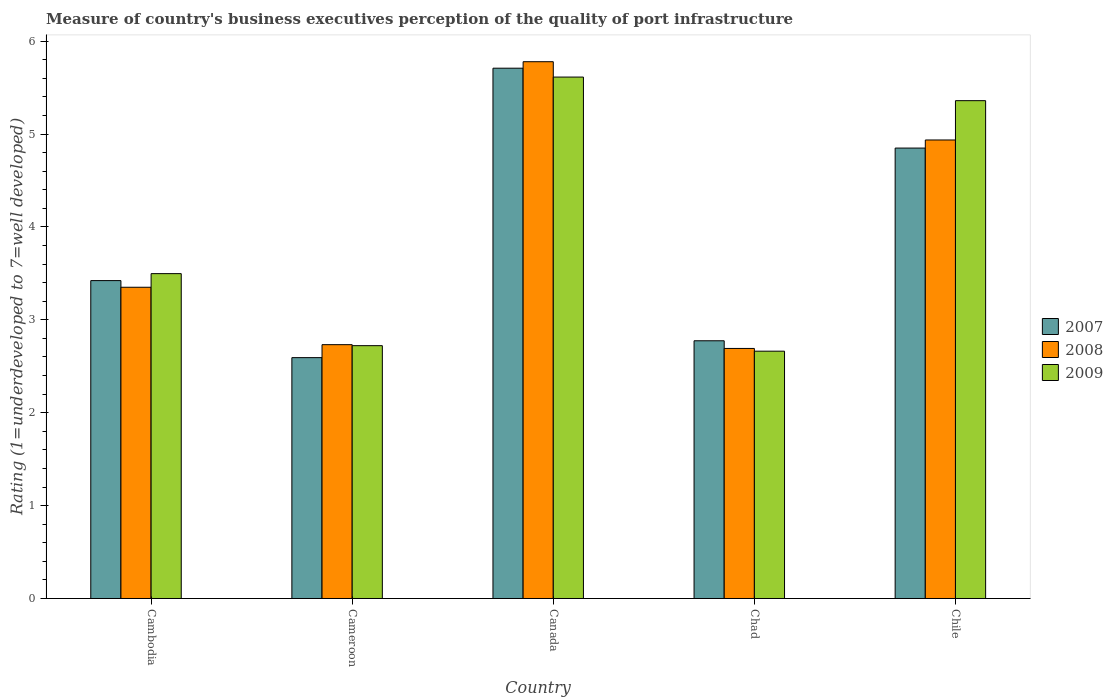How many different coloured bars are there?
Keep it short and to the point. 3. How many groups of bars are there?
Keep it short and to the point. 5. Are the number of bars per tick equal to the number of legend labels?
Your answer should be compact. Yes. How many bars are there on the 5th tick from the left?
Give a very brief answer. 3. What is the label of the 1st group of bars from the left?
Provide a succinct answer. Cambodia. In how many cases, is the number of bars for a given country not equal to the number of legend labels?
Make the answer very short. 0. What is the ratings of the quality of port infrastructure in 2008 in Cameroon?
Ensure brevity in your answer.  2.73. Across all countries, what is the maximum ratings of the quality of port infrastructure in 2007?
Your response must be concise. 5.71. Across all countries, what is the minimum ratings of the quality of port infrastructure in 2007?
Offer a very short reply. 2.59. In which country was the ratings of the quality of port infrastructure in 2008 minimum?
Offer a terse response. Chad. What is the total ratings of the quality of port infrastructure in 2009 in the graph?
Offer a very short reply. 19.85. What is the difference between the ratings of the quality of port infrastructure in 2008 in Cameroon and that in Canada?
Make the answer very short. -3.05. What is the difference between the ratings of the quality of port infrastructure in 2007 in Cameroon and the ratings of the quality of port infrastructure in 2008 in Canada?
Offer a terse response. -3.19. What is the average ratings of the quality of port infrastructure in 2008 per country?
Provide a succinct answer. 3.9. What is the difference between the ratings of the quality of port infrastructure of/in 2009 and ratings of the quality of port infrastructure of/in 2008 in Cambodia?
Offer a very short reply. 0.15. What is the ratio of the ratings of the quality of port infrastructure in 2008 in Canada to that in Chad?
Give a very brief answer. 2.15. What is the difference between the highest and the second highest ratings of the quality of port infrastructure in 2007?
Provide a short and direct response. -1.43. What is the difference between the highest and the lowest ratings of the quality of port infrastructure in 2008?
Your answer should be compact. 3.09. In how many countries, is the ratings of the quality of port infrastructure in 2008 greater than the average ratings of the quality of port infrastructure in 2008 taken over all countries?
Ensure brevity in your answer.  2. What does the 3rd bar from the left in Cambodia represents?
Your response must be concise. 2009. Is it the case that in every country, the sum of the ratings of the quality of port infrastructure in 2007 and ratings of the quality of port infrastructure in 2008 is greater than the ratings of the quality of port infrastructure in 2009?
Make the answer very short. Yes. Are all the bars in the graph horizontal?
Make the answer very short. No. How many countries are there in the graph?
Offer a terse response. 5. Does the graph contain any zero values?
Ensure brevity in your answer.  No. Does the graph contain grids?
Keep it short and to the point. No. How many legend labels are there?
Your answer should be compact. 3. How are the legend labels stacked?
Ensure brevity in your answer.  Vertical. What is the title of the graph?
Give a very brief answer. Measure of country's business executives perception of the quality of port infrastructure. Does "1997" appear as one of the legend labels in the graph?
Your answer should be compact. No. What is the label or title of the Y-axis?
Provide a succinct answer. Rating (1=underdeveloped to 7=well developed). What is the Rating (1=underdeveloped to 7=well developed) of 2007 in Cambodia?
Provide a succinct answer. 3.42. What is the Rating (1=underdeveloped to 7=well developed) in 2008 in Cambodia?
Offer a very short reply. 3.35. What is the Rating (1=underdeveloped to 7=well developed) of 2009 in Cambodia?
Your answer should be very brief. 3.5. What is the Rating (1=underdeveloped to 7=well developed) in 2007 in Cameroon?
Provide a short and direct response. 2.59. What is the Rating (1=underdeveloped to 7=well developed) in 2008 in Cameroon?
Ensure brevity in your answer.  2.73. What is the Rating (1=underdeveloped to 7=well developed) of 2009 in Cameroon?
Your answer should be compact. 2.72. What is the Rating (1=underdeveloped to 7=well developed) in 2007 in Canada?
Offer a terse response. 5.71. What is the Rating (1=underdeveloped to 7=well developed) of 2008 in Canada?
Your answer should be compact. 5.78. What is the Rating (1=underdeveloped to 7=well developed) of 2009 in Canada?
Offer a terse response. 5.61. What is the Rating (1=underdeveloped to 7=well developed) of 2007 in Chad?
Ensure brevity in your answer.  2.77. What is the Rating (1=underdeveloped to 7=well developed) of 2008 in Chad?
Your response must be concise. 2.69. What is the Rating (1=underdeveloped to 7=well developed) in 2009 in Chad?
Give a very brief answer. 2.66. What is the Rating (1=underdeveloped to 7=well developed) of 2007 in Chile?
Make the answer very short. 4.85. What is the Rating (1=underdeveloped to 7=well developed) of 2008 in Chile?
Provide a succinct answer. 4.94. What is the Rating (1=underdeveloped to 7=well developed) in 2009 in Chile?
Your answer should be compact. 5.36. Across all countries, what is the maximum Rating (1=underdeveloped to 7=well developed) in 2007?
Provide a short and direct response. 5.71. Across all countries, what is the maximum Rating (1=underdeveloped to 7=well developed) in 2008?
Make the answer very short. 5.78. Across all countries, what is the maximum Rating (1=underdeveloped to 7=well developed) of 2009?
Keep it short and to the point. 5.61. Across all countries, what is the minimum Rating (1=underdeveloped to 7=well developed) of 2007?
Provide a short and direct response. 2.59. Across all countries, what is the minimum Rating (1=underdeveloped to 7=well developed) in 2008?
Your answer should be very brief. 2.69. Across all countries, what is the minimum Rating (1=underdeveloped to 7=well developed) in 2009?
Ensure brevity in your answer.  2.66. What is the total Rating (1=underdeveloped to 7=well developed) of 2007 in the graph?
Give a very brief answer. 19.35. What is the total Rating (1=underdeveloped to 7=well developed) in 2008 in the graph?
Provide a succinct answer. 19.49. What is the total Rating (1=underdeveloped to 7=well developed) of 2009 in the graph?
Ensure brevity in your answer.  19.85. What is the difference between the Rating (1=underdeveloped to 7=well developed) of 2007 in Cambodia and that in Cameroon?
Keep it short and to the point. 0.83. What is the difference between the Rating (1=underdeveloped to 7=well developed) of 2008 in Cambodia and that in Cameroon?
Offer a terse response. 0.62. What is the difference between the Rating (1=underdeveloped to 7=well developed) of 2009 in Cambodia and that in Cameroon?
Offer a terse response. 0.78. What is the difference between the Rating (1=underdeveloped to 7=well developed) in 2007 in Cambodia and that in Canada?
Provide a succinct answer. -2.29. What is the difference between the Rating (1=underdeveloped to 7=well developed) in 2008 in Cambodia and that in Canada?
Provide a short and direct response. -2.43. What is the difference between the Rating (1=underdeveloped to 7=well developed) in 2009 in Cambodia and that in Canada?
Offer a very short reply. -2.12. What is the difference between the Rating (1=underdeveloped to 7=well developed) in 2007 in Cambodia and that in Chad?
Make the answer very short. 0.65. What is the difference between the Rating (1=underdeveloped to 7=well developed) in 2008 in Cambodia and that in Chad?
Offer a very short reply. 0.66. What is the difference between the Rating (1=underdeveloped to 7=well developed) in 2009 in Cambodia and that in Chad?
Provide a succinct answer. 0.83. What is the difference between the Rating (1=underdeveloped to 7=well developed) in 2007 in Cambodia and that in Chile?
Give a very brief answer. -1.43. What is the difference between the Rating (1=underdeveloped to 7=well developed) of 2008 in Cambodia and that in Chile?
Your answer should be very brief. -1.59. What is the difference between the Rating (1=underdeveloped to 7=well developed) in 2009 in Cambodia and that in Chile?
Ensure brevity in your answer.  -1.86. What is the difference between the Rating (1=underdeveloped to 7=well developed) of 2007 in Cameroon and that in Canada?
Provide a short and direct response. -3.12. What is the difference between the Rating (1=underdeveloped to 7=well developed) in 2008 in Cameroon and that in Canada?
Ensure brevity in your answer.  -3.05. What is the difference between the Rating (1=underdeveloped to 7=well developed) in 2009 in Cameroon and that in Canada?
Ensure brevity in your answer.  -2.89. What is the difference between the Rating (1=underdeveloped to 7=well developed) of 2007 in Cameroon and that in Chad?
Keep it short and to the point. -0.18. What is the difference between the Rating (1=underdeveloped to 7=well developed) in 2008 in Cameroon and that in Chad?
Provide a short and direct response. 0.04. What is the difference between the Rating (1=underdeveloped to 7=well developed) of 2009 in Cameroon and that in Chad?
Provide a short and direct response. 0.06. What is the difference between the Rating (1=underdeveloped to 7=well developed) in 2007 in Cameroon and that in Chile?
Provide a succinct answer. -2.26. What is the difference between the Rating (1=underdeveloped to 7=well developed) in 2008 in Cameroon and that in Chile?
Keep it short and to the point. -2.2. What is the difference between the Rating (1=underdeveloped to 7=well developed) of 2009 in Cameroon and that in Chile?
Offer a terse response. -2.64. What is the difference between the Rating (1=underdeveloped to 7=well developed) in 2007 in Canada and that in Chad?
Offer a terse response. 2.93. What is the difference between the Rating (1=underdeveloped to 7=well developed) of 2008 in Canada and that in Chad?
Give a very brief answer. 3.09. What is the difference between the Rating (1=underdeveloped to 7=well developed) in 2009 in Canada and that in Chad?
Give a very brief answer. 2.95. What is the difference between the Rating (1=underdeveloped to 7=well developed) in 2007 in Canada and that in Chile?
Your answer should be compact. 0.86. What is the difference between the Rating (1=underdeveloped to 7=well developed) of 2008 in Canada and that in Chile?
Offer a very short reply. 0.84. What is the difference between the Rating (1=underdeveloped to 7=well developed) in 2009 in Canada and that in Chile?
Provide a short and direct response. 0.25. What is the difference between the Rating (1=underdeveloped to 7=well developed) in 2007 in Chad and that in Chile?
Offer a very short reply. -2.07. What is the difference between the Rating (1=underdeveloped to 7=well developed) of 2008 in Chad and that in Chile?
Provide a succinct answer. -2.24. What is the difference between the Rating (1=underdeveloped to 7=well developed) of 2009 in Chad and that in Chile?
Keep it short and to the point. -2.7. What is the difference between the Rating (1=underdeveloped to 7=well developed) in 2007 in Cambodia and the Rating (1=underdeveloped to 7=well developed) in 2008 in Cameroon?
Provide a succinct answer. 0.69. What is the difference between the Rating (1=underdeveloped to 7=well developed) in 2007 in Cambodia and the Rating (1=underdeveloped to 7=well developed) in 2009 in Cameroon?
Your answer should be compact. 0.7. What is the difference between the Rating (1=underdeveloped to 7=well developed) in 2008 in Cambodia and the Rating (1=underdeveloped to 7=well developed) in 2009 in Cameroon?
Provide a short and direct response. 0.63. What is the difference between the Rating (1=underdeveloped to 7=well developed) in 2007 in Cambodia and the Rating (1=underdeveloped to 7=well developed) in 2008 in Canada?
Provide a short and direct response. -2.36. What is the difference between the Rating (1=underdeveloped to 7=well developed) of 2007 in Cambodia and the Rating (1=underdeveloped to 7=well developed) of 2009 in Canada?
Provide a short and direct response. -2.19. What is the difference between the Rating (1=underdeveloped to 7=well developed) in 2008 in Cambodia and the Rating (1=underdeveloped to 7=well developed) in 2009 in Canada?
Give a very brief answer. -2.26. What is the difference between the Rating (1=underdeveloped to 7=well developed) in 2007 in Cambodia and the Rating (1=underdeveloped to 7=well developed) in 2008 in Chad?
Offer a very short reply. 0.73. What is the difference between the Rating (1=underdeveloped to 7=well developed) of 2007 in Cambodia and the Rating (1=underdeveloped to 7=well developed) of 2009 in Chad?
Ensure brevity in your answer.  0.76. What is the difference between the Rating (1=underdeveloped to 7=well developed) in 2008 in Cambodia and the Rating (1=underdeveloped to 7=well developed) in 2009 in Chad?
Offer a terse response. 0.69. What is the difference between the Rating (1=underdeveloped to 7=well developed) in 2007 in Cambodia and the Rating (1=underdeveloped to 7=well developed) in 2008 in Chile?
Make the answer very short. -1.51. What is the difference between the Rating (1=underdeveloped to 7=well developed) in 2007 in Cambodia and the Rating (1=underdeveloped to 7=well developed) in 2009 in Chile?
Ensure brevity in your answer.  -1.94. What is the difference between the Rating (1=underdeveloped to 7=well developed) in 2008 in Cambodia and the Rating (1=underdeveloped to 7=well developed) in 2009 in Chile?
Provide a short and direct response. -2.01. What is the difference between the Rating (1=underdeveloped to 7=well developed) of 2007 in Cameroon and the Rating (1=underdeveloped to 7=well developed) of 2008 in Canada?
Your answer should be compact. -3.19. What is the difference between the Rating (1=underdeveloped to 7=well developed) of 2007 in Cameroon and the Rating (1=underdeveloped to 7=well developed) of 2009 in Canada?
Make the answer very short. -3.02. What is the difference between the Rating (1=underdeveloped to 7=well developed) of 2008 in Cameroon and the Rating (1=underdeveloped to 7=well developed) of 2009 in Canada?
Your answer should be compact. -2.88. What is the difference between the Rating (1=underdeveloped to 7=well developed) in 2007 in Cameroon and the Rating (1=underdeveloped to 7=well developed) in 2008 in Chad?
Offer a terse response. -0.1. What is the difference between the Rating (1=underdeveloped to 7=well developed) in 2007 in Cameroon and the Rating (1=underdeveloped to 7=well developed) in 2009 in Chad?
Ensure brevity in your answer.  -0.07. What is the difference between the Rating (1=underdeveloped to 7=well developed) of 2008 in Cameroon and the Rating (1=underdeveloped to 7=well developed) of 2009 in Chad?
Ensure brevity in your answer.  0.07. What is the difference between the Rating (1=underdeveloped to 7=well developed) in 2007 in Cameroon and the Rating (1=underdeveloped to 7=well developed) in 2008 in Chile?
Give a very brief answer. -2.34. What is the difference between the Rating (1=underdeveloped to 7=well developed) in 2007 in Cameroon and the Rating (1=underdeveloped to 7=well developed) in 2009 in Chile?
Give a very brief answer. -2.77. What is the difference between the Rating (1=underdeveloped to 7=well developed) in 2008 in Cameroon and the Rating (1=underdeveloped to 7=well developed) in 2009 in Chile?
Offer a terse response. -2.63. What is the difference between the Rating (1=underdeveloped to 7=well developed) in 2007 in Canada and the Rating (1=underdeveloped to 7=well developed) in 2008 in Chad?
Keep it short and to the point. 3.02. What is the difference between the Rating (1=underdeveloped to 7=well developed) of 2007 in Canada and the Rating (1=underdeveloped to 7=well developed) of 2009 in Chad?
Offer a very short reply. 3.05. What is the difference between the Rating (1=underdeveloped to 7=well developed) of 2008 in Canada and the Rating (1=underdeveloped to 7=well developed) of 2009 in Chad?
Provide a succinct answer. 3.12. What is the difference between the Rating (1=underdeveloped to 7=well developed) in 2007 in Canada and the Rating (1=underdeveloped to 7=well developed) in 2008 in Chile?
Offer a very short reply. 0.77. What is the difference between the Rating (1=underdeveloped to 7=well developed) in 2007 in Canada and the Rating (1=underdeveloped to 7=well developed) in 2009 in Chile?
Provide a succinct answer. 0.35. What is the difference between the Rating (1=underdeveloped to 7=well developed) in 2008 in Canada and the Rating (1=underdeveloped to 7=well developed) in 2009 in Chile?
Provide a succinct answer. 0.42. What is the difference between the Rating (1=underdeveloped to 7=well developed) of 2007 in Chad and the Rating (1=underdeveloped to 7=well developed) of 2008 in Chile?
Provide a short and direct response. -2.16. What is the difference between the Rating (1=underdeveloped to 7=well developed) of 2007 in Chad and the Rating (1=underdeveloped to 7=well developed) of 2009 in Chile?
Ensure brevity in your answer.  -2.58. What is the difference between the Rating (1=underdeveloped to 7=well developed) of 2008 in Chad and the Rating (1=underdeveloped to 7=well developed) of 2009 in Chile?
Your answer should be compact. -2.67. What is the average Rating (1=underdeveloped to 7=well developed) in 2007 per country?
Make the answer very short. 3.87. What is the average Rating (1=underdeveloped to 7=well developed) of 2008 per country?
Your answer should be very brief. 3.9. What is the average Rating (1=underdeveloped to 7=well developed) in 2009 per country?
Ensure brevity in your answer.  3.97. What is the difference between the Rating (1=underdeveloped to 7=well developed) of 2007 and Rating (1=underdeveloped to 7=well developed) of 2008 in Cambodia?
Offer a very short reply. 0.07. What is the difference between the Rating (1=underdeveloped to 7=well developed) of 2007 and Rating (1=underdeveloped to 7=well developed) of 2009 in Cambodia?
Keep it short and to the point. -0.08. What is the difference between the Rating (1=underdeveloped to 7=well developed) of 2008 and Rating (1=underdeveloped to 7=well developed) of 2009 in Cambodia?
Ensure brevity in your answer.  -0.15. What is the difference between the Rating (1=underdeveloped to 7=well developed) of 2007 and Rating (1=underdeveloped to 7=well developed) of 2008 in Cameroon?
Your answer should be very brief. -0.14. What is the difference between the Rating (1=underdeveloped to 7=well developed) in 2007 and Rating (1=underdeveloped to 7=well developed) in 2009 in Cameroon?
Your answer should be very brief. -0.13. What is the difference between the Rating (1=underdeveloped to 7=well developed) in 2008 and Rating (1=underdeveloped to 7=well developed) in 2009 in Cameroon?
Give a very brief answer. 0.01. What is the difference between the Rating (1=underdeveloped to 7=well developed) of 2007 and Rating (1=underdeveloped to 7=well developed) of 2008 in Canada?
Your answer should be very brief. -0.07. What is the difference between the Rating (1=underdeveloped to 7=well developed) of 2007 and Rating (1=underdeveloped to 7=well developed) of 2009 in Canada?
Keep it short and to the point. 0.1. What is the difference between the Rating (1=underdeveloped to 7=well developed) of 2008 and Rating (1=underdeveloped to 7=well developed) of 2009 in Canada?
Your answer should be very brief. 0.17. What is the difference between the Rating (1=underdeveloped to 7=well developed) in 2007 and Rating (1=underdeveloped to 7=well developed) in 2008 in Chad?
Your response must be concise. 0.08. What is the difference between the Rating (1=underdeveloped to 7=well developed) of 2007 and Rating (1=underdeveloped to 7=well developed) of 2009 in Chad?
Keep it short and to the point. 0.11. What is the difference between the Rating (1=underdeveloped to 7=well developed) in 2008 and Rating (1=underdeveloped to 7=well developed) in 2009 in Chad?
Keep it short and to the point. 0.03. What is the difference between the Rating (1=underdeveloped to 7=well developed) in 2007 and Rating (1=underdeveloped to 7=well developed) in 2008 in Chile?
Your answer should be very brief. -0.09. What is the difference between the Rating (1=underdeveloped to 7=well developed) of 2007 and Rating (1=underdeveloped to 7=well developed) of 2009 in Chile?
Offer a very short reply. -0.51. What is the difference between the Rating (1=underdeveloped to 7=well developed) in 2008 and Rating (1=underdeveloped to 7=well developed) in 2009 in Chile?
Ensure brevity in your answer.  -0.42. What is the ratio of the Rating (1=underdeveloped to 7=well developed) of 2007 in Cambodia to that in Cameroon?
Your response must be concise. 1.32. What is the ratio of the Rating (1=underdeveloped to 7=well developed) in 2008 in Cambodia to that in Cameroon?
Provide a short and direct response. 1.23. What is the ratio of the Rating (1=underdeveloped to 7=well developed) of 2009 in Cambodia to that in Cameroon?
Keep it short and to the point. 1.28. What is the ratio of the Rating (1=underdeveloped to 7=well developed) of 2007 in Cambodia to that in Canada?
Ensure brevity in your answer.  0.6. What is the ratio of the Rating (1=underdeveloped to 7=well developed) in 2008 in Cambodia to that in Canada?
Give a very brief answer. 0.58. What is the ratio of the Rating (1=underdeveloped to 7=well developed) of 2009 in Cambodia to that in Canada?
Provide a succinct answer. 0.62. What is the ratio of the Rating (1=underdeveloped to 7=well developed) in 2007 in Cambodia to that in Chad?
Offer a very short reply. 1.23. What is the ratio of the Rating (1=underdeveloped to 7=well developed) of 2008 in Cambodia to that in Chad?
Offer a very short reply. 1.24. What is the ratio of the Rating (1=underdeveloped to 7=well developed) in 2009 in Cambodia to that in Chad?
Your answer should be compact. 1.31. What is the ratio of the Rating (1=underdeveloped to 7=well developed) in 2007 in Cambodia to that in Chile?
Offer a terse response. 0.71. What is the ratio of the Rating (1=underdeveloped to 7=well developed) of 2008 in Cambodia to that in Chile?
Provide a succinct answer. 0.68. What is the ratio of the Rating (1=underdeveloped to 7=well developed) of 2009 in Cambodia to that in Chile?
Your answer should be compact. 0.65. What is the ratio of the Rating (1=underdeveloped to 7=well developed) in 2007 in Cameroon to that in Canada?
Ensure brevity in your answer.  0.45. What is the ratio of the Rating (1=underdeveloped to 7=well developed) of 2008 in Cameroon to that in Canada?
Ensure brevity in your answer.  0.47. What is the ratio of the Rating (1=underdeveloped to 7=well developed) in 2009 in Cameroon to that in Canada?
Provide a succinct answer. 0.48. What is the ratio of the Rating (1=underdeveloped to 7=well developed) in 2007 in Cameroon to that in Chad?
Offer a very short reply. 0.93. What is the ratio of the Rating (1=underdeveloped to 7=well developed) of 2008 in Cameroon to that in Chad?
Offer a terse response. 1.02. What is the ratio of the Rating (1=underdeveloped to 7=well developed) of 2009 in Cameroon to that in Chad?
Your response must be concise. 1.02. What is the ratio of the Rating (1=underdeveloped to 7=well developed) of 2007 in Cameroon to that in Chile?
Provide a short and direct response. 0.53. What is the ratio of the Rating (1=underdeveloped to 7=well developed) of 2008 in Cameroon to that in Chile?
Keep it short and to the point. 0.55. What is the ratio of the Rating (1=underdeveloped to 7=well developed) of 2009 in Cameroon to that in Chile?
Offer a very short reply. 0.51. What is the ratio of the Rating (1=underdeveloped to 7=well developed) in 2007 in Canada to that in Chad?
Make the answer very short. 2.06. What is the ratio of the Rating (1=underdeveloped to 7=well developed) of 2008 in Canada to that in Chad?
Your answer should be very brief. 2.15. What is the ratio of the Rating (1=underdeveloped to 7=well developed) of 2009 in Canada to that in Chad?
Offer a very short reply. 2.11. What is the ratio of the Rating (1=underdeveloped to 7=well developed) in 2007 in Canada to that in Chile?
Offer a very short reply. 1.18. What is the ratio of the Rating (1=underdeveloped to 7=well developed) of 2008 in Canada to that in Chile?
Your answer should be compact. 1.17. What is the ratio of the Rating (1=underdeveloped to 7=well developed) of 2009 in Canada to that in Chile?
Make the answer very short. 1.05. What is the ratio of the Rating (1=underdeveloped to 7=well developed) in 2007 in Chad to that in Chile?
Make the answer very short. 0.57. What is the ratio of the Rating (1=underdeveloped to 7=well developed) of 2008 in Chad to that in Chile?
Your answer should be very brief. 0.55. What is the ratio of the Rating (1=underdeveloped to 7=well developed) in 2009 in Chad to that in Chile?
Provide a succinct answer. 0.5. What is the difference between the highest and the second highest Rating (1=underdeveloped to 7=well developed) of 2007?
Ensure brevity in your answer.  0.86. What is the difference between the highest and the second highest Rating (1=underdeveloped to 7=well developed) of 2008?
Your response must be concise. 0.84. What is the difference between the highest and the second highest Rating (1=underdeveloped to 7=well developed) in 2009?
Your answer should be compact. 0.25. What is the difference between the highest and the lowest Rating (1=underdeveloped to 7=well developed) of 2007?
Offer a very short reply. 3.12. What is the difference between the highest and the lowest Rating (1=underdeveloped to 7=well developed) in 2008?
Your answer should be very brief. 3.09. What is the difference between the highest and the lowest Rating (1=underdeveloped to 7=well developed) of 2009?
Your answer should be very brief. 2.95. 